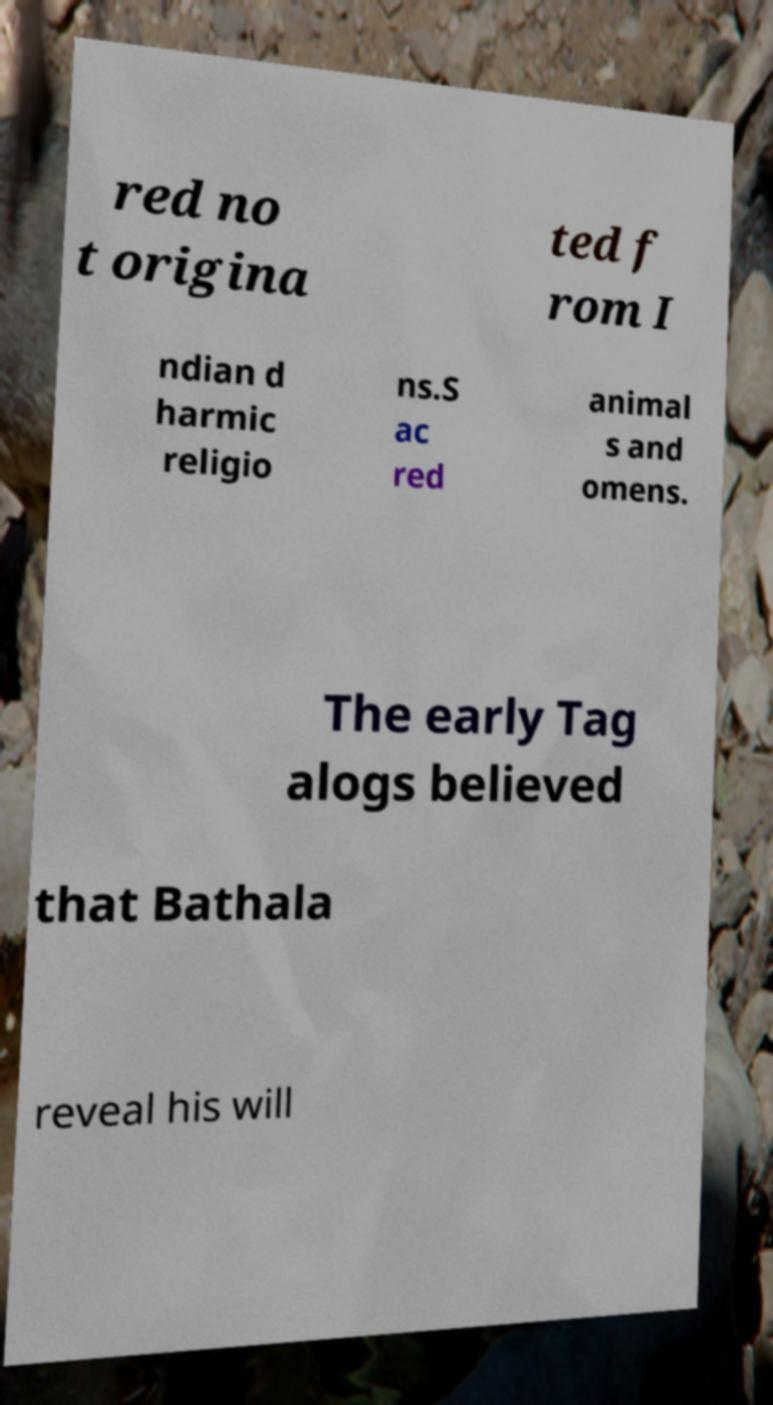For documentation purposes, I need the text within this image transcribed. Could you provide that? red no t origina ted f rom I ndian d harmic religio ns.S ac red animal s and omens. The early Tag alogs believed that Bathala reveal his will 